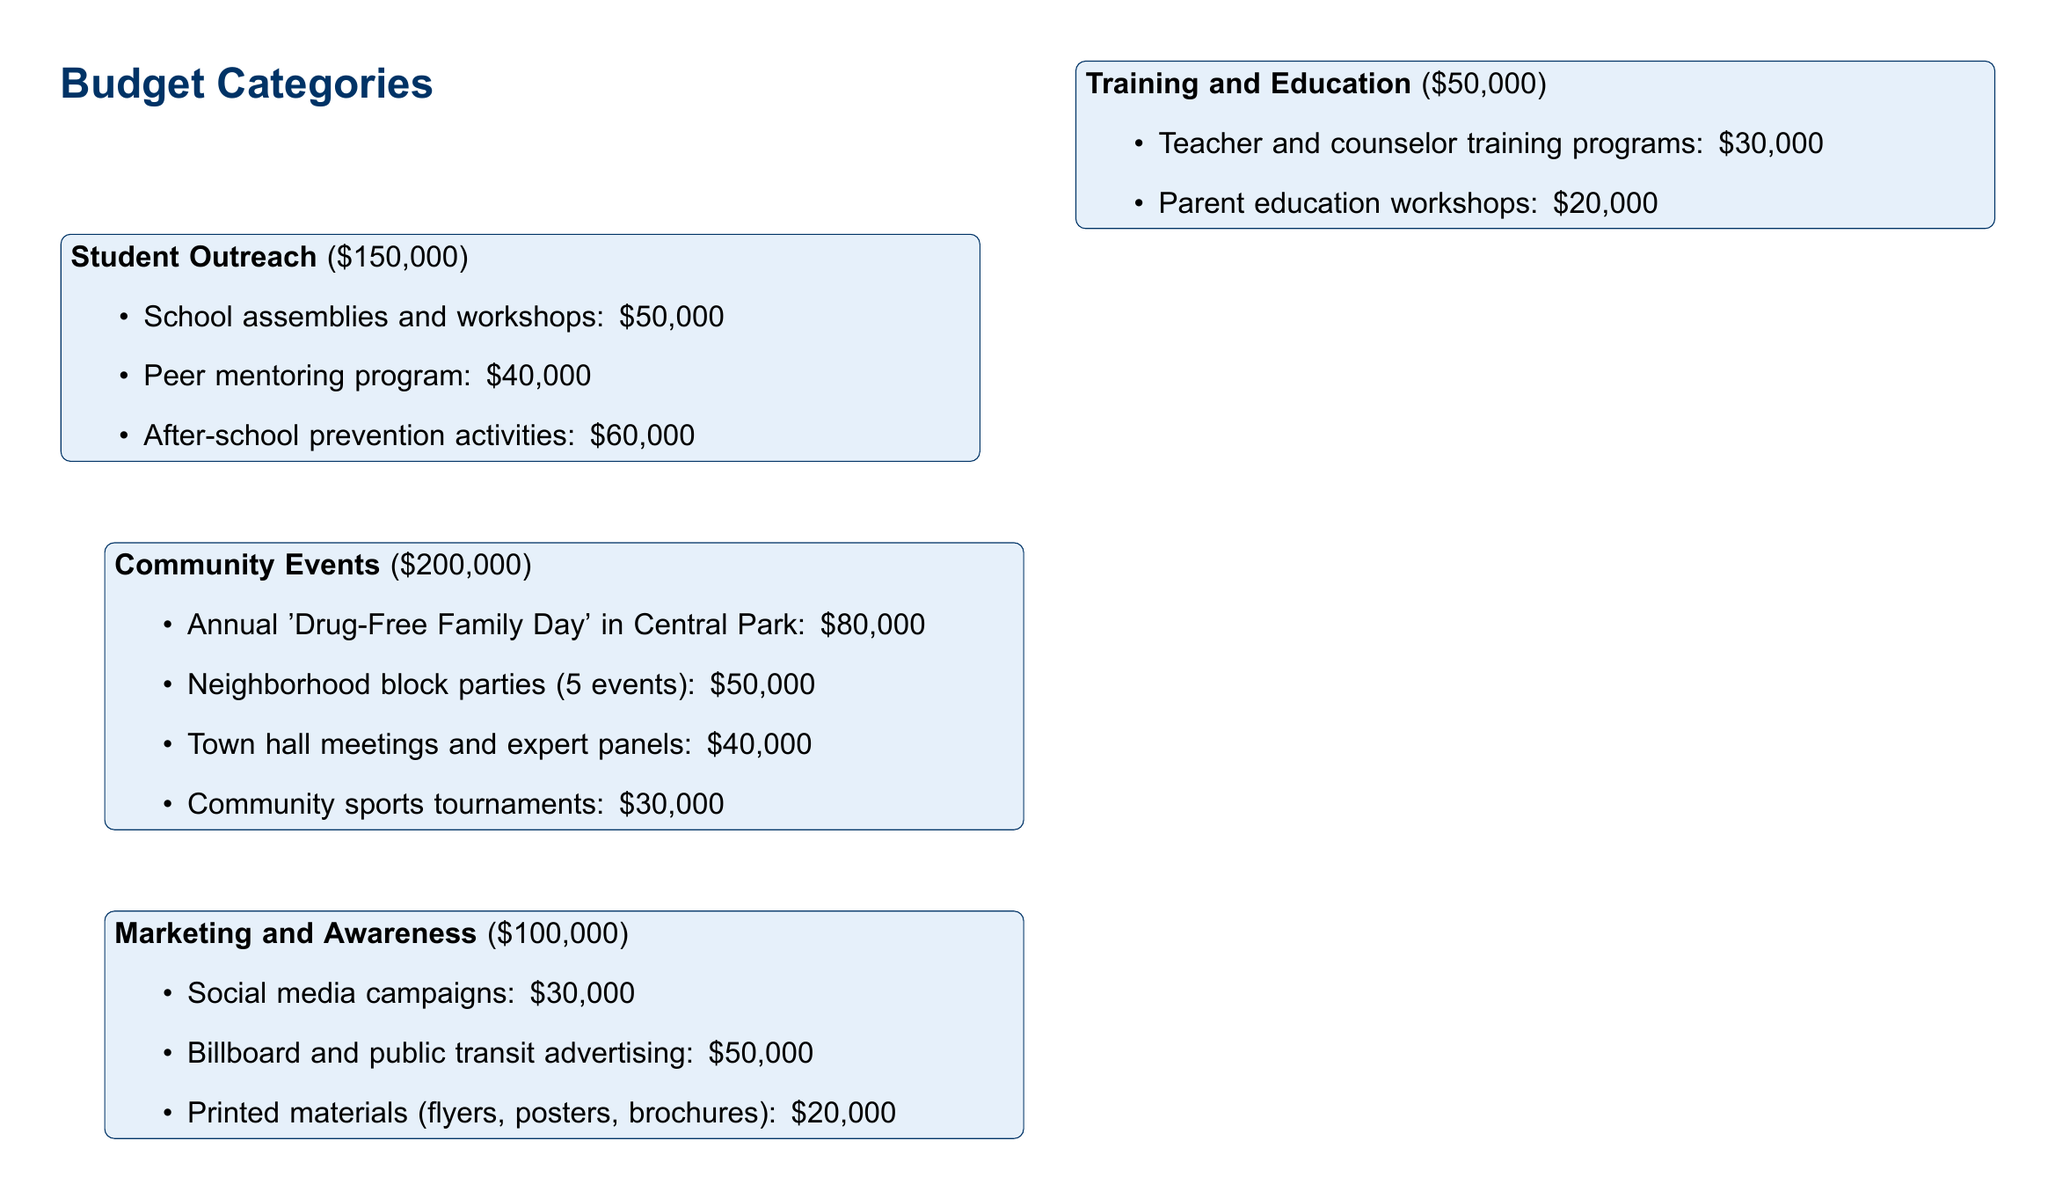What is the total budget for the campaign? The total budget is explicitly stated at the top of the document as $500,000.
Answer: $500,000 How much is allocated for the community events? The document specifies the allocation for community events at $200,000.
Answer: $200,000 What is the budget for school assemblies and workshops? The amount allocated for school assemblies and workshops is provided under student outreach, which is $50,000.
Answer: $50,000 What is one of the evaluation metrics listed in the document? The document lists several evaluation metrics, including "Reduction in youth drug use rates."
Answer: Reduction in youth drug use rates How many neighborhood block parties are planned? The document states that there will be 5 neighborhood block parties planned as part of the community events.
Answer: 5 